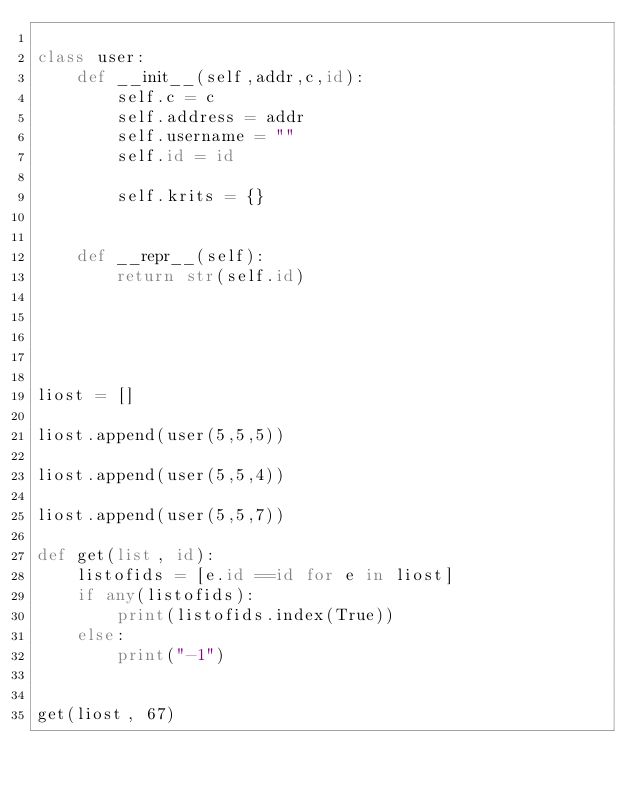<code> <loc_0><loc_0><loc_500><loc_500><_Python_>
class user:
    def __init__(self,addr,c,id):
        self.c = c
        self.address = addr
        self.username = ""
        self.id = id

        self.krits = {}
        

    def __repr__(self):
        return str(self.id)





liost = []

liost.append(user(5,5,5))

liost.append(user(5,5,4))

liost.append(user(5,5,7))

def get(list, id):
    listofids = [e.id ==id for e in liost]
    if any(listofids):
        print(listofids.index(True))
    else:
        print("-1")
    

get(liost, 67)</code> 